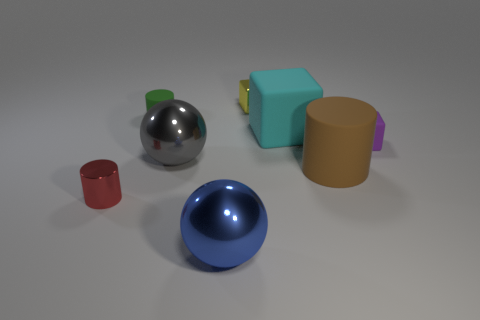What number of things are tiny rubber cylinders or big blocks?
Provide a short and direct response. 2. Are there any matte cylinders?
Your response must be concise. Yes. What is the material of the sphere that is left of the big sphere that is in front of the tiny cylinder in front of the big rubber cylinder?
Give a very brief answer. Metal. Is the number of small green things to the left of the tiny red thing less than the number of big purple spheres?
Provide a short and direct response. No. There is a cube that is the same size as the brown matte cylinder; what material is it?
Your answer should be compact. Rubber. What size is the rubber thing that is both to the right of the green thing and left of the large brown object?
Keep it short and to the point. Large. There is a brown object that is the same shape as the small green matte object; what is its size?
Offer a terse response. Large. How many things are yellow rubber cylinders or metal things in front of the yellow shiny block?
Provide a succinct answer. 3. What shape is the red object?
Keep it short and to the point. Cylinder. What shape is the yellow thing that is behind the tiny matte object on the left side of the tiny metal block?
Offer a very short reply. Cube. 